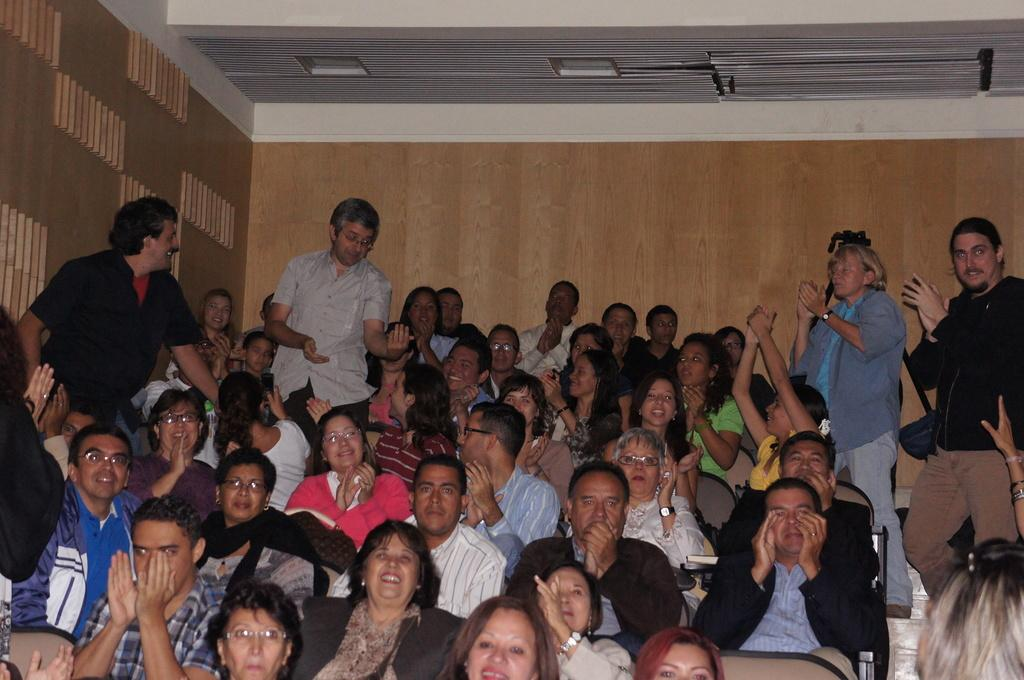How many people are in the image? There are people in the image, but the exact number is not specified. What are some of the people doing in the image? Some people are sitting on chairs, and some are standing. What can be seen on the ceiling in the image? There are lights on the ceiling. Can you describe the object behind a person in the image? There is an object behind a person, but its description is not provided. How many dogs are attempting to jump through the person's throat in the image? There are no dogs or throats mentioned in the image, so this scenario cannot be observed. 